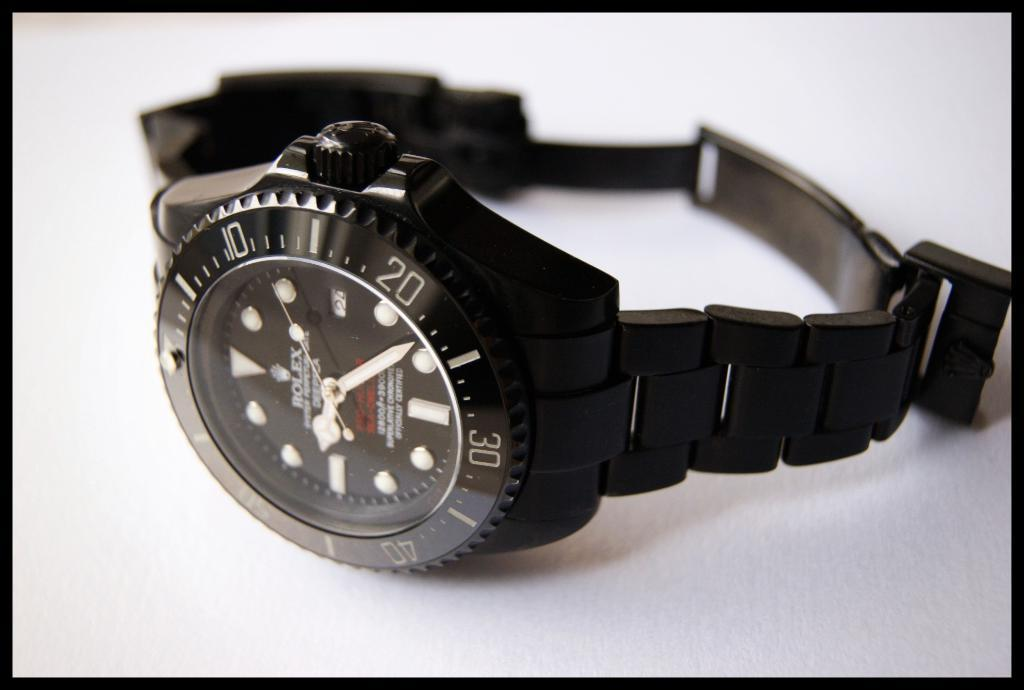<image>
Create a compact narrative representing the image presented. A rolex watch lays on its side on a white background 